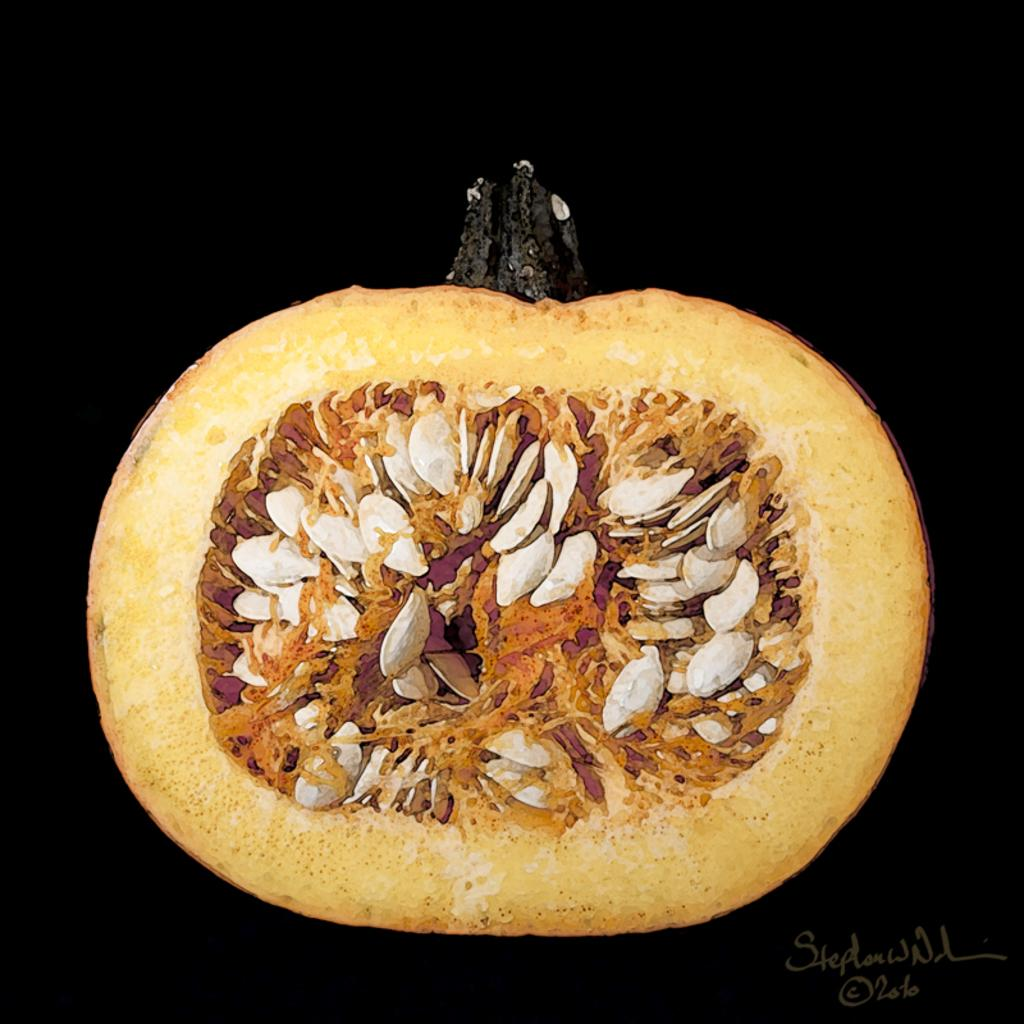What is the main subject of the image? The main subject of the image is a pumpkin. Can you describe the colors of the pumpkin? The pumpkin has brown and white colors. What can be observed about the background of the image? The background of the image is dark. What type of match is being played in the image? There is no match being played in the image; it features a pumpkin with brown and white colors against a dark background. Can you provide a list of the judges in the image? There are no judges present in the image, as it only features a pumpkin. 